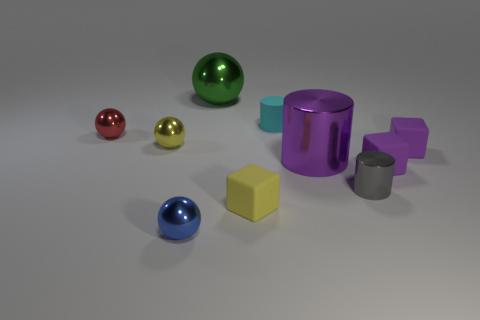Subtract all yellow blocks. How many blocks are left? 2 Subtract all yellow cubes. How many cubes are left? 2 Subtract 2 blocks. How many blocks are left? 1 Add 9 big balls. How many big balls exist? 10 Subtract 0 red cylinders. How many objects are left? 10 Subtract all cylinders. How many objects are left? 7 Subtract all purple blocks. Subtract all green spheres. How many blocks are left? 1 Subtract all yellow cylinders. How many blue blocks are left? 0 Subtract all red things. Subtract all blue things. How many objects are left? 8 Add 2 yellow metallic objects. How many yellow metallic objects are left? 3 